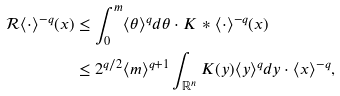<formula> <loc_0><loc_0><loc_500><loc_500>\mathcal { R } \langle \cdot \rangle ^ { - q } ( x ) & \leq \int _ { 0 } ^ { m } \langle \theta \rangle ^ { q } d \theta \cdot K \ast \langle \cdot \rangle ^ { - q } ( x ) \\ & \leq 2 ^ { q / 2 } \langle m \rangle ^ { q + 1 } \int _ { \mathbb { R } ^ { n } } K ( y ) \langle y \rangle ^ { q } d y \cdot \langle x \rangle ^ { - q } ,</formula> 